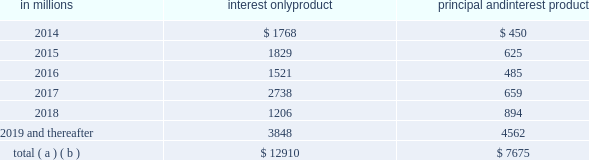Charge-off is based on pnc 2019s actual loss experience for each type of pool .
Since a pool may consist of first and second liens , the charge-off amounts for the pool are proportionate to the composition of first and second liens in the pool .
Our experience has been that the ratio of first to second lien loans has been consistent over time and is appropriately represented in our pools used for roll-rate calculations .
Generally , our variable-rate home equity lines of credit have either a seven or ten year draw period , followed by a 20-year amortization term .
During the draw period , we have home equity lines of credit where borrowers pay interest only and home equity lines of credit where borrowers pay principal and interest .
The risk associated with our home equity lines of credit end of period draw dates is considered in establishing our alll .
Based upon outstanding balances at december 31 , 2013 , the table presents the periods when home equity lines of credit draw periods are scheduled to end .
Table 41 : home equity lines of credit 2013 draw period end in millions interest only product principal and interest product .
( a ) includes all home equity lines of credit that mature in 2014 or later , including those with borrowers where we have terminated borrowing privileges .
( b ) includes approximately $ 185 million , $ 193 million , $ 54 million , $ 63 million , $ 47 million and $ 561 million of home equity lines of credit with balloon payments , including those where we have terminated borrowing privileges , with draw periods scheduled to end in 2014 , 2015 , 2016 , 2017 , 2018 and 2019 and thereafter , respectively .
We view home equity lines of credit where borrowers are paying principal and interest under the draw period as less risky than those where the borrowers are paying interest only , as these borrowers have a demonstrated ability to make some level of principal and interest payments .
Based upon outstanding balances , and excluding purchased impaired loans , at december 31 , 2013 , for home equity lines of credit for which the borrower can no longer draw ( e.g. , draw period has ended or borrowing privileges have been terminated ) , approximately 3.65% ( 3.65 % ) were 30-89 days past due and approximately 5.49% ( 5.49 % ) were 90 days or more past due .
Generally , when a borrower becomes 60 days past due , we terminate borrowing privileges and those privileges are not subsequently reinstated .
At that point , we continue our collection/recovery processes , which may include a loss mitigation loan modification resulting in a loan that is classified as a tdr .
See note 5 asset quality in the notes to consolidated financial statements in item 8 of this report for additional information .
Loan modifications and troubled debt restructurings consumer loan modifications we modify loans under government and pnc-developed programs based upon our commitment to help eligible homeowners and borrowers avoid foreclosure , where appropriate .
Initially , a borrower is evaluated for a modification under a government program .
If a borrower does not qualify under a government program , the borrower is then evaluated under a pnc program .
Our programs utilize both temporary and permanent modifications and typically reduce the interest rate , extend the term and/or defer principal .
Temporary and permanent modifications under programs involving a change to loan terms are generally classified as tdrs .
Further , certain payment plans and trial payment arrangements which do not include a contractual change to loan terms may be classified as tdrs .
Additional detail on tdrs is discussed below as well as in note 5 asset quality in the notes to consolidated financial statements in item 8 of this report .
A temporary modification , with a term between 3 and 24 months , involves a change in original loan terms for a period of time and reverts to a calculated exit rate for the remaining term of the loan as of a specific date .
A permanent modification , with a term greater than 24 months , is a modification in which the terms of the original loan are changed .
Permanent modifications primarily include the government-created home affordable modification program ( hamp ) or pnc-developed hamp-like modification programs .
For home equity lines of credit , we will enter into a temporary modification when the borrower has indicated a temporary hardship and a willingness to bring current the delinquent loan balance .
Examples of this situation often include delinquency due to illness or death in the family or loss of employment .
Permanent modifications are entered into when it is confirmed that the borrower does not possess the income necessary to continue making loan payments at the current amount , but our expectation is that payments at lower amounts can be made .
We also monitor the success rates and delinquency status of our loan modification programs to assess their effectiveness in serving our customers 2019 needs while mitigating credit losses .
Table 42 provides the number of accounts and unpaid principal balance of modified consumer real estate related loans and table 43 provides the number of accounts and unpaid principal balance of modified loans that were 60 days or more past due as of six months , nine months , twelve months and fifteen months after the modification date .
The pnc financial services group , inc .
2013 form 10-k 79 .
At december 31 , 2013 , for home equity lines of credit for which the borrower can no longer draw ( e.g . , draw period has ended or borrowing privileges have been terminated ) , approximately what percent were 30-89 days past due and 90 days or more past due? 
Computations: (3.65 + 5.49)
Answer: 9.14. 